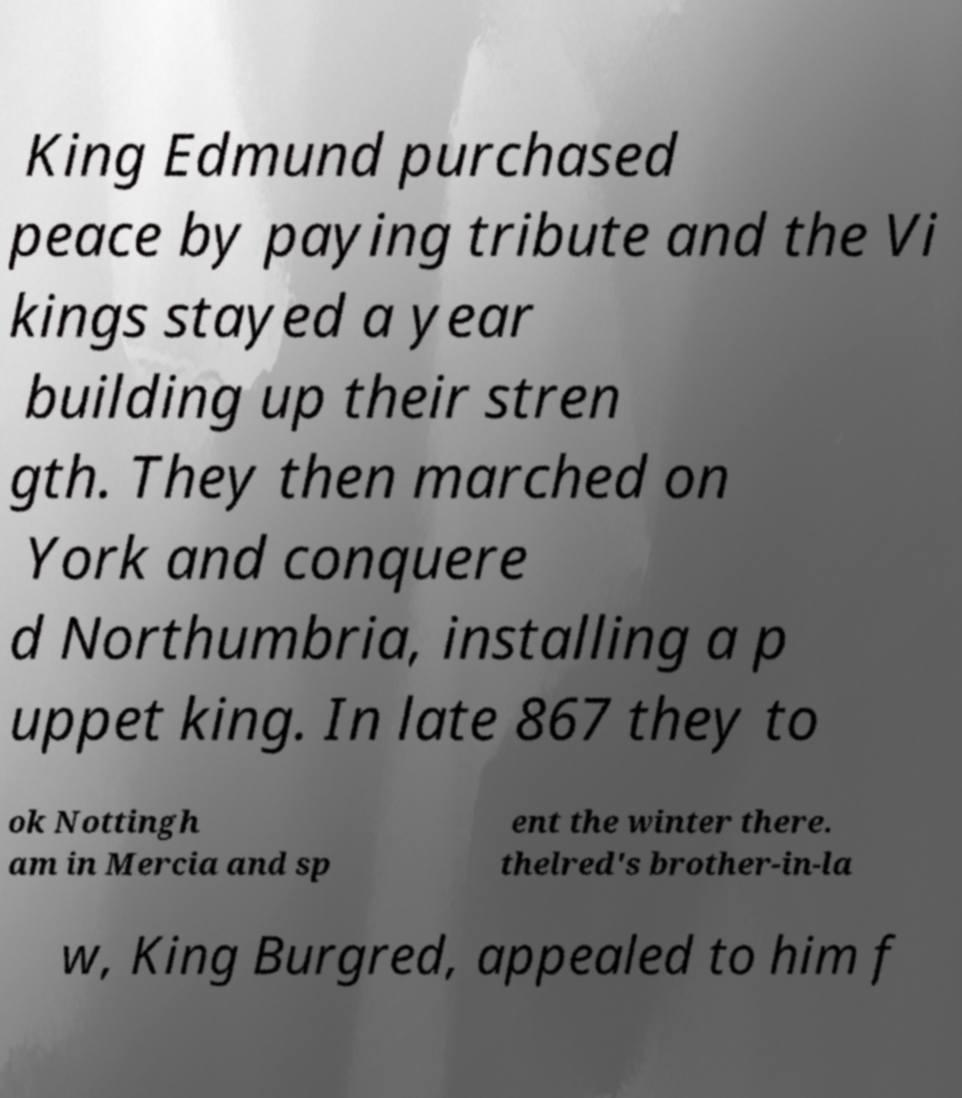Please read and relay the text visible in this image. What does it say? King Edmund purchased peace by paying tribute and the Vi kings stayed a year building up their stren gth. They then marched on York and conquere d Northumbria, installing a p uppet king. In late 867 they to ok Nottingh am in Mercia and sp ent the winter there. thelred's brother-in-la w, King Burgred, appealed to him f 